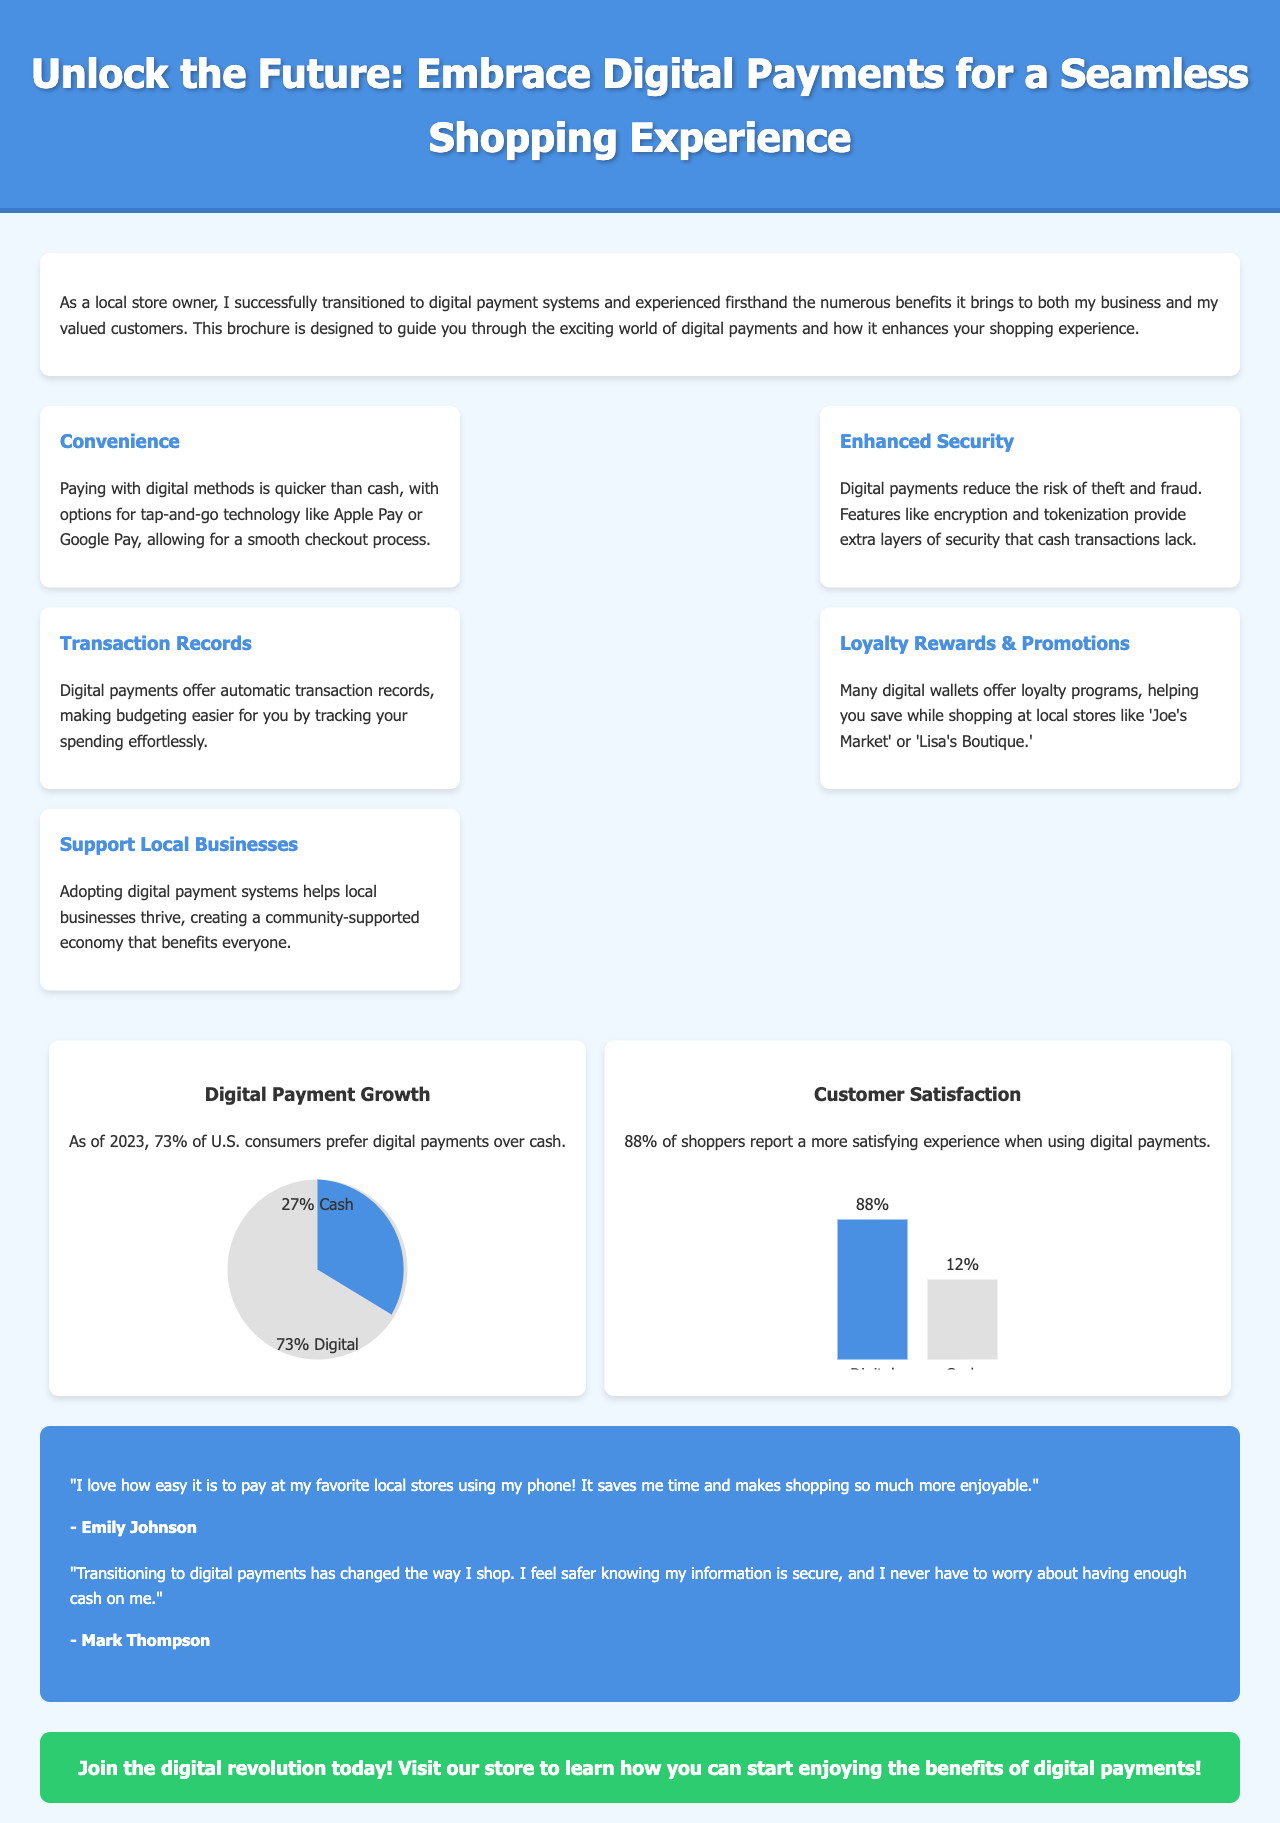What is the title of the brochure? The title is prominently displayed at the top of the document.
Answer: Unlock the Future: Embrace Digital Payments for a Seamless Shopping Experience What percentage of U.S. consumers prefer digital payments over cash? The infographic presents a specific statistic regarding consumer preference for payment methods.
Answer: 73% What are the benefits outlined in the brochure? The document lists multiple benefits in separate sections, highlighting various advantages.
Answer: Convenience, Enhanced Security, Transaction Records, Loyalty Rewards & Promotions, Support Local Businesses What is the customer satisfaction percentage when using digital payments? This information is illustrated in an infographic within the document.
Answer: 88% Who provided a testimonial about enjoying digital payments? The testimonials feature quotes from satisfied customers who appreciate the convenience of digital payments.
Answer: Emily Johnson What color is the call to action section? The call to action section is described in relation to its visual design.
Answer: Green Why is digital payment adoption beneficial for local businesses? The document mentions community and economic support as reasons for adopting digital payments.
Answer: It helps local businesses thrive How do digital payments improve budgeting? The document describes the automatic record-keeping feature of digital transactions.
Answer: By tracking spending effortlessly 